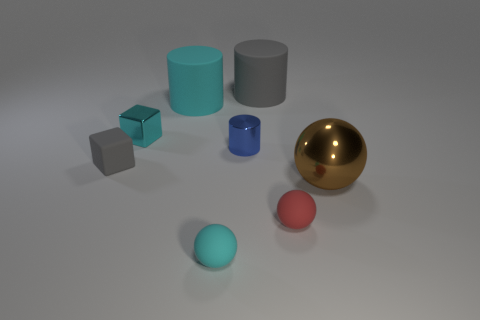Subtract all cylinders. How many objects are left? 5 Add 6 brown metal spheres. How many brown metal spheres are left? 7 Add 2 tiny gray matte cubes. How many tiny gray matte cubes exist? 3 Subtract 1 red balls. How many objects are left? 7 Subtract all small shiny cylinders. Subtract all blocks. How many objects are left? 5 